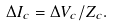Convert formula to latex. <formula><loc_0><loc_0><loc_500><loc_500>\Delta I _ { c } = \Delta V _ { c } / Z _ { c } .</formula> 